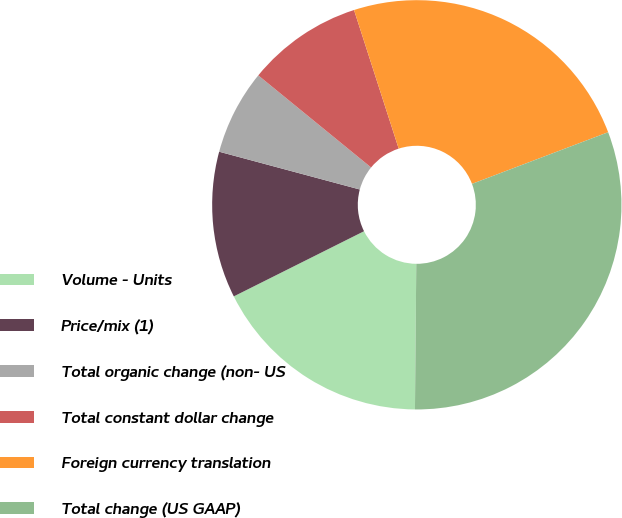Convert chart to OTSL. <chart><loc_0><loc_0><loc_500><loc_500><pie_chart><fcel>Volume - Units<fcel>Price/mix (1)<fcel>Total organic change (non- US<fcel>Total constant dollar change<fcel>Foreign currency translation<fcel>Total change (US GAAP)<nl><fcel>17.47%<fcel>11.56%<fcel>6.72%<fcel>9.14%<fcel>24.19%<fcel>30.91%<nl></chart> 